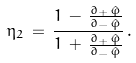<formula> <loc_0><loc_0><loc_500><loc_500>\eta _ { 2 } \, = \, \frac { 1 \, - \, { \frac { \partial _ { + } \, \hat { \varphi } } { \partial _ { - } \, \hat { \varphi } } } } { 1 \, + \, { \frac { \partial _ { + } \, \hat { \varphi } } { \partial _ { - } \, \hat { \varphi } } } } \, .</formula> 